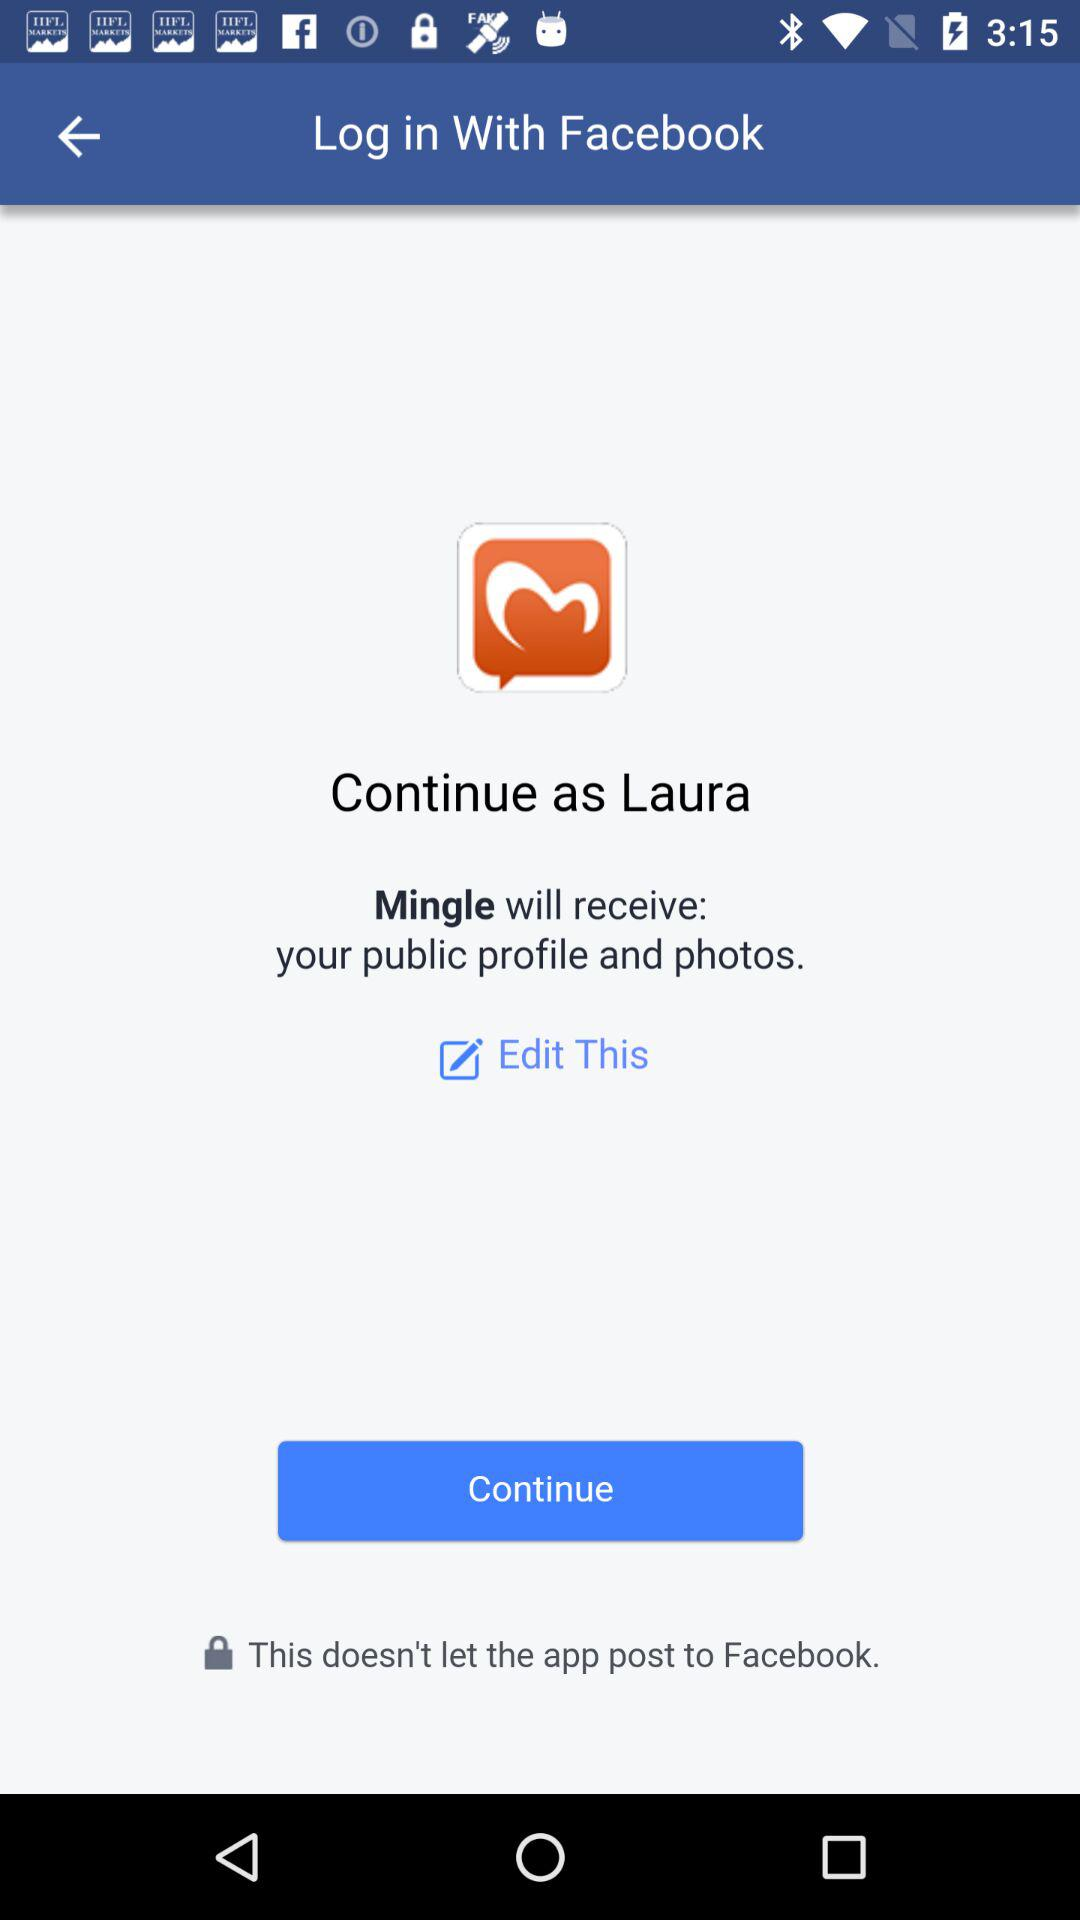What application will receive my public profile and photos? The application "Mingle" will receive your public profile and photos. 